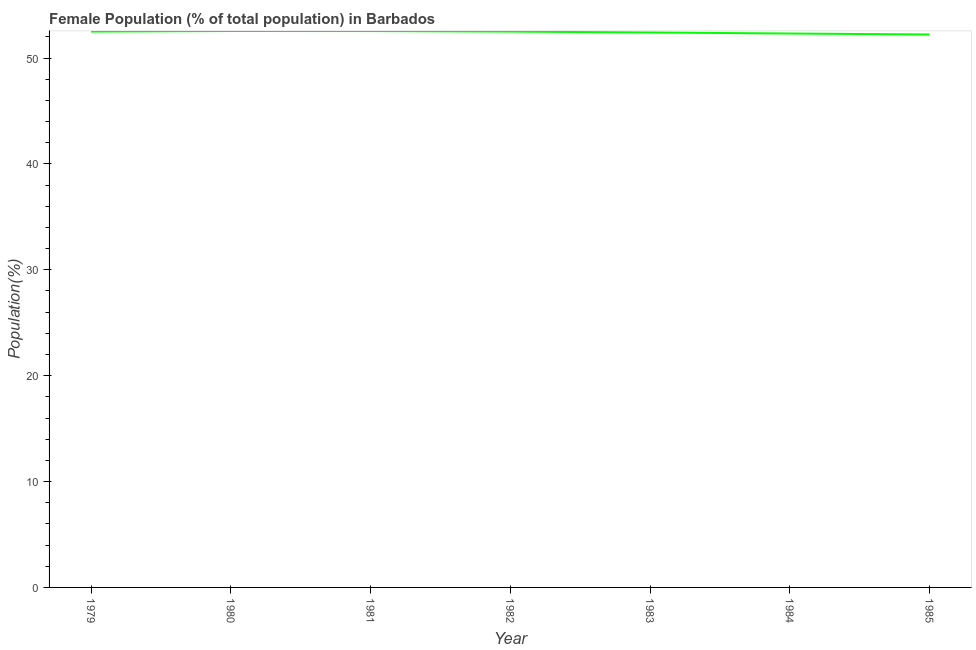What is the female population in 1981?
Make the answer very short. 52.55. Across all years, what is the maximum female population?
Offer a terse response. 52.56. Across all years, what is the minimum female population?
Make the answer very short. 52.23. What is the sum of the female population?
Provide a succinct answer. 367.08. What is the difference between the female population in 1982 and 1983?
Ensure brevity in your answer.  0.08. What is the average female population per year?
Your answer should be compact. 52.44. What is the median female population?
Offer a very short reply. 52.5. Do a majority of the years between 1981 and 1984 (inclusive) have female population greater than 16 %?
Make the answer very short. Yes. What is the ratio of the female population in 1980 to that in 1981?
Your response must be concise. 1. Is the female population in 1980 less than that in 1982?
Provide a succinct answer. No. Is the difference between the female population in 1982 and 1985 greater than the difference between any two years?
Make the answer very short. No. What is the difference between the highest and the second highest female population?
Give a very brief answer. 0. What is the difference between the highest and the lowest female population?
Provide a succinct answer. 0.33. In how many years, is the female population greater than the average female population taken over all years?
Offer a terse response. 4. Does the graph contain any zero values?
Provide a succinct answer. No. What is the title of the graph?
Your answer should be very brief. Female Population (% of total population) in Barbados. What is the label or title of the X-axis?
Provide a short and direct response. Year. What is the label or title of the Y-axis?
Your answer should be very brief. Population(%). What is the Population(%) of 1979?
Provide a succinct answer. 52.5. What is the Population(%) in 1980?
Your answer should be very brief. 52.56. What is the Population(%) in 1981?
Give a very brief answer. 52.55. What is the Population(%) of 1982?
Your answer should be very brief. 52.5. What is the Population(%) of 1983?
Your answer should be compact. 52.42. What is the Population(%) of 1984?
Make the answer very short. 52.32. What is the Population(%) of 1985?
Your answer should be very brief. 52.23. What is the difference between the Population(%) in 1979 and 1980?
Your answer should be compact. -0.05. What is the difference between the Population(%) in 1979 and 1981?
Keep it short and to the point. -0.05. What is the difference between the Population(%) in 1979 and 1982?
Offer a very short reply. 0. What is the difference between the Population(%) in 1979 and 1983?
Your answer should be very brief. 0.09. What is the difference between the Population(%) in 1979 and 1984?
Your answer should be compact. 0.18. What is the difference between the Population(%) in 1979 and 1985?
Provide a succinct answer. 0.28. What is the difference between the Population(%) in 1980 and 1981?
Provide a short and direct response. 0. What is the difference between the Population(%) in 1980 and 1982?
Your response must be concise. 0.06. What is the difference between the Population(%) in 1980 and 1983?
Offer a terse response. 0.14. What is the difference between the Population(%) in 1980 and 1984?
Your answer should be compact. 0.24. What is the difference between the Population(%) in 1980 and 1985?
Offer a terse response. 0.33. What is the difference between the Population(%) in 1981 and 1982?
Make the answer very short. 0.05. What is the difference between the Population(%) in 1981 and 1983?
Give a very brief answer. 0.14. What is the difference between the Population(%) in 1981 and 1984?
Offer a very short reply. 0.23. What is the difference between the Population(%) in 1981 and 1985?
Provide a short and direct response. 0.33. What is the difference between the Population(%) in 1982 and 1983?
Offer a terse response. 0.08. What is the difference between the Population(%) in 1982 and 1984?
Make the answer very short. 0.18. What is the difference between the Population(%) in 1982 and 1985?
Give a very brief answer. 0.27. What is the difference between the Population(%) in 1983 and 1984?
Your answer should be compact. 0.1. What is the difference between the Population(%) in 1983 and 1985?
Your answer should be very brief. 0.19. What is the difference between the Population(%) in 1984 and 1985?
Your answer should be very brief. 0.09. What is the ratio of the Population(%) in 1979 to that in 1980?
Your answer should be very brief. 1. What is the ratio of the Population(%) in 1979 to that in 1982?
Keep it short and to the point. 1. What is the ratio of the Population(%) in 1979 to that in 1985?
Your response must be concise. 1. What is the ratio of the Population(%) in 1981 to that in 1982?
Offer a terse response. 1. What is the ratio of the Population(%) in 1981 to that in 1983?
Provide a short and direct response. 1. What is the ratio of the Population(%) in 1981 to that in 1985?
Provide a succinct answer. 1.01. What is the ratio of the Population(%) in 1982 to that in 1983?
Give a very brief answer. 1. What is the ratio of the Population(%) in 1982 to that in 1985?
Your answer should be very brief. 1. What is the ratio of the Population(%) in 1984 to that in 1985?
Ensure brevity in your answer.  1. 